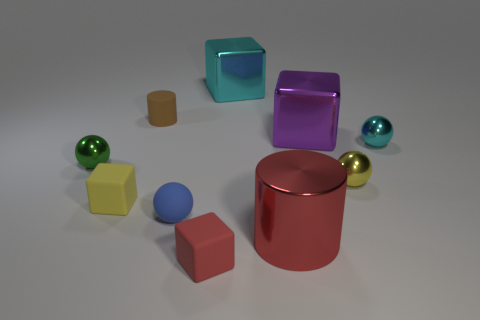Subtract all spheres. How many objects are left? 6 Subtract all small green spheres. Subtract all cylinders. How many objects are left? 7 Add 5 small metal objects. How many small metal objects are left? 8 Add 5 red metal cylinders. How many red metal cylinders exist? 6 Subtract 1 cyan spheres. How many objects are left? 9 